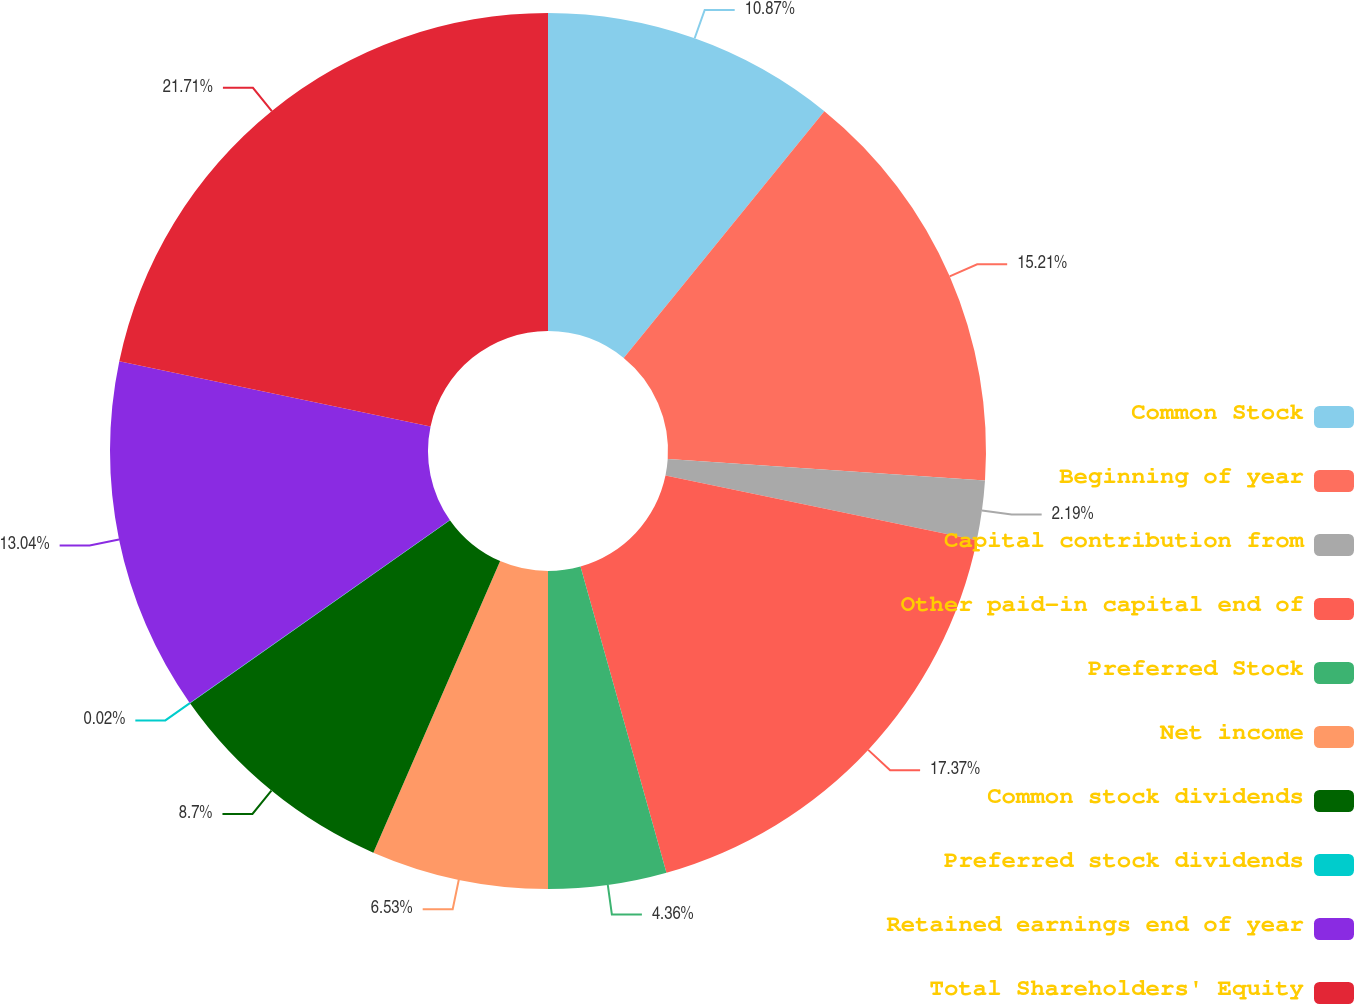<chart> <loc_0><loc_0><loc_500><loc_500><pie_chart><fcel>Common Stock<fcel>Beginning of year<fcel>Capital contribution from<fcel>Other paid-in capital end of<fcel>Preferred Stock<fcel>Net income<fcel>Common stock dividends<fcel>Preferred stock dividends<fcel>Retained earnings end of year<fcel>Total Shareholders' Equity<nl><fcel>10.87%<fcel>15.21%<fcel>2.19%<fcel>17.38%<fcel>4.36%<fcel>6.53%<fcel>8.7%<fcel>0.02%<fcel>13.04%<fcel>21.72%<nl></chart> 